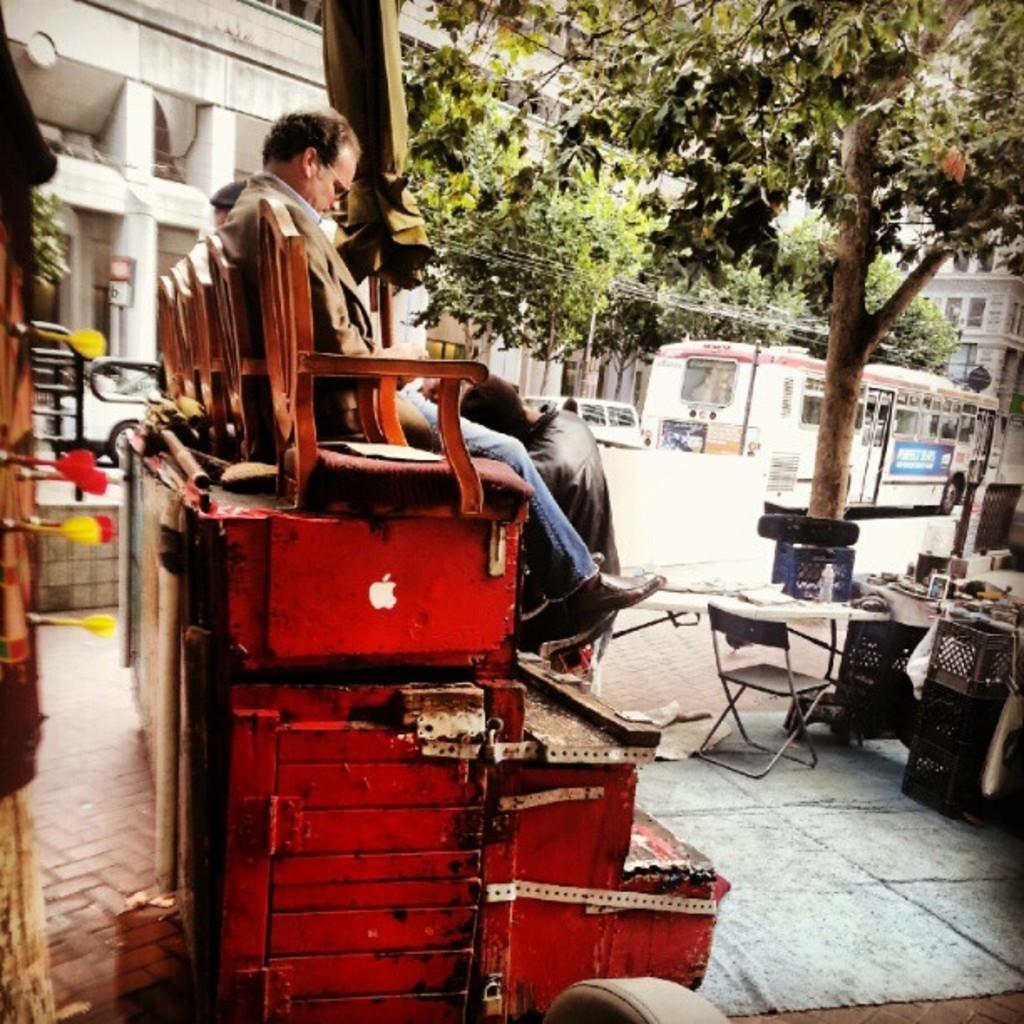What are the people in the image doing? The people in the image are sitting on chairs. What type of natural elements can be seen in the image? Trees are visible in the image. What type of man-made structures can be seen in the image? Buildings are visible in the image. What type of infrastructure is present in the image? There is an electrical cable in the image. Can you describe the object on the left side of the image? Unfortunately, the facts provided do not specify the nature of the object on the left side of the image. What type of cloud can be seen covering the veil of the plastic object in the image? There is no cloud, veil, or plastic object present in the image. 